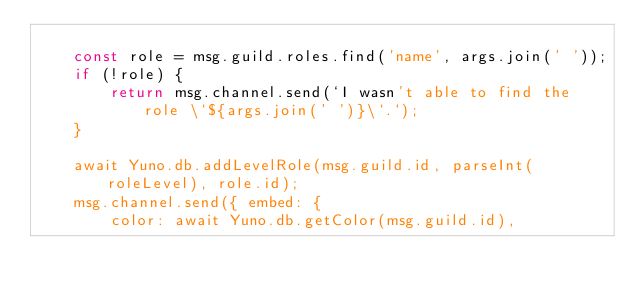Convert code to text. <code><loc_0><loc_0><loc_500><loc_500><_JavaScript_>
    const role = msg.guild.roles.find('name', args.join(' '));
    if (!role) {
        return msg.channel.send(`I wasn't able to find the role \`${args.join(' ')}\`.`);
    }

    await Yuno.db.addLevelRole(msg.guild.id, parseInt(roleLevel), role.id);
    msg.channel.send({ embed: {
        color: await Yuno.db.getColor(msg.guild.id),</code> 